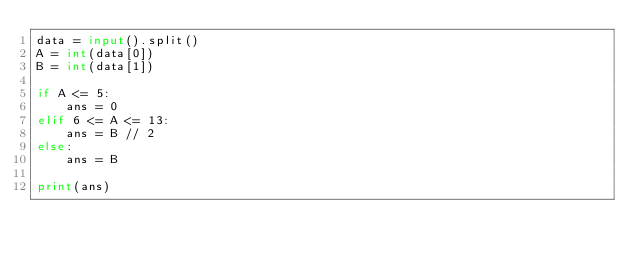Convert code to text. <code><loc_0><loc_0><loc_500><loc_500><_Python_>data = input().split()
A = int(data[0])
B = int(data[1])

if A <= 5:
    ans = 0
elif 6 <= A <= 13:
    ans = B // 2
else:
    ans = B

print(ans)</code> 